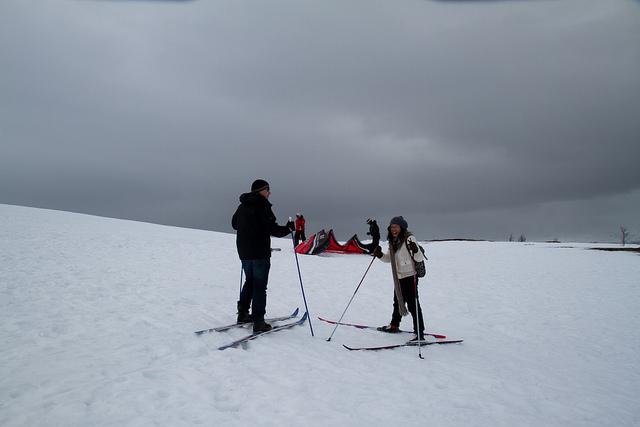What are these people standing on?
Be succinct. Skis. Is the snow deep?
Keep it brief. Yes. Is the man moving?
Keep it brief. No. What position are the skier's legs in?
Concise answer only. Straight. Is there a mountain in the distance?
Be succinct. No. Is there any snow in the photo?
Short answer required. Yes. Is there rubble on the ground?
Concise answer only. No. What are they standing on?
Concise answer only. Snow. 